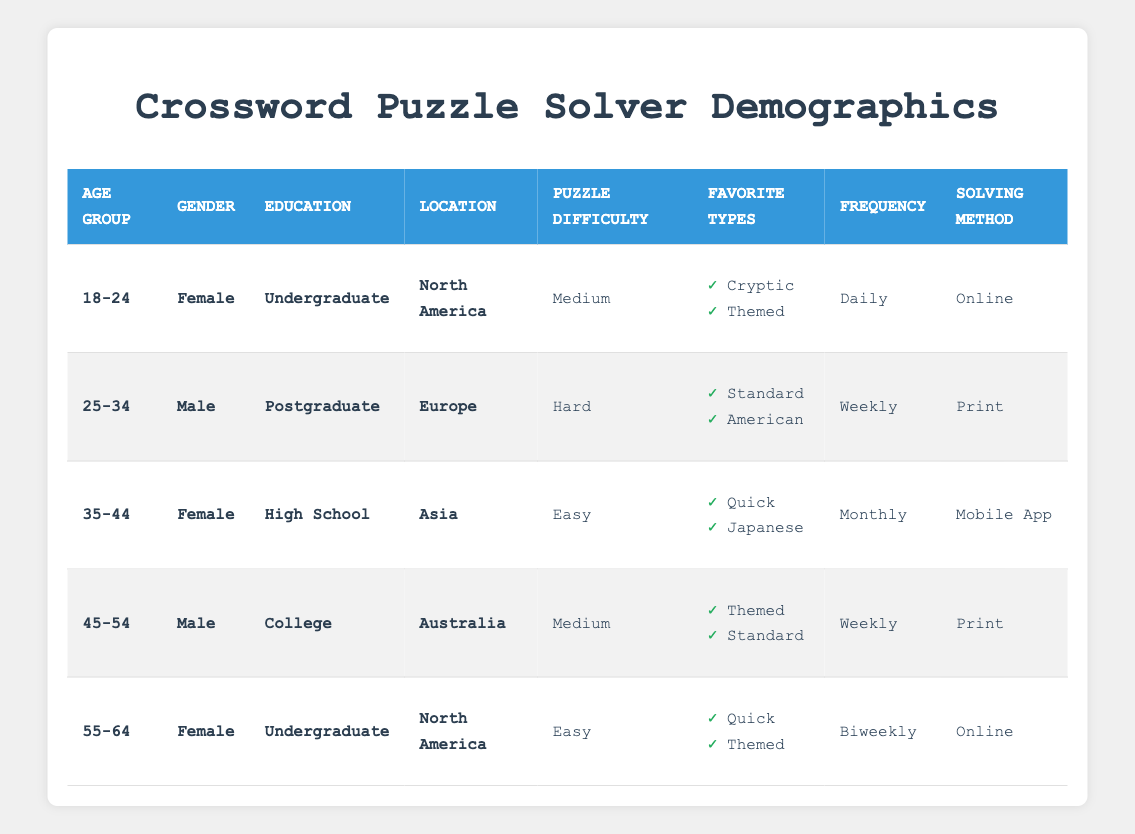What is the preferred solving method for the 18-24 age group? In the table, under the demographic for age group 18-24, the preferred solving method is listed as "Online."
Answer: Online How many of the solvers have a preference for "Standard" puzzle types? We look at each preferences cell in the table. The 25-34 age group and the 45-54 age group both list "Standard" as a favorite type. Summing them gives us 2 solvers preferring "Standard."
Answer: 2 Is there any solver aged 35-44 who prefers "Hard" puzzle difficulty? Checking the table, the 35-44 age group has a puzzle difficulty preference of "Easy," not "Hard." Therefore, the answer is false.
Answer: No Which geographical location has a solver that prefers "Biweekly" solving frequency? Under the demographic for the 55-64 age group, we see that the geographic location is "North America," and the solving frequency is stated as "Biweekly."
Answer: North America What is the average age of the crossword puzzle solvers in the table? The age groups are: 18-24, 25-34, 35-44, 45-54, and 55-64. We convert these to midpoints: 21, 29.5, 39.5, 49.5, and 59.5. Adding them gives 199 and dividing it by the number of groups (5) results in an average age of 39.8.
Answer: 39.8 What is the most common education level among the crossword puzzle solvers? Looking at the education levels, we have: Undergraduate (2), Postgraduate (1), High School (1), and College (1). Undergraduate appears most frequently, indicating it is the most common education level.
Answer: Undergraduate Is there a solver from Asia who solves puzzles daily? In the table, the solver from Asia is in the 35-44 age group and solves puzzles monthly, not daily. Thus, the statement is false.
Answer: No What puzzle difficulty level do the majority of males prefer? From the data, males aged 25-34 prefer "Hard" and those aged 45-54 prefer "Medium." Since there are no males preferring "Easy," and "Medium" and "Hard" are equally favored, the most preferred difficulty for males cannot be determined with the majority but can be stated as "Medium or Hard."
Answer: Medium or Hard 